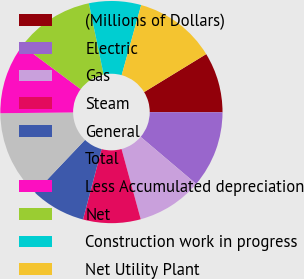Convert chart. <chart><loc_0><loc_0><loc_500><loc_500><pie_chart><fcel>(Millions of Dollars)<fcel>Electric<fcel>Gas<fcel>Steam<fcel>General<fcel>Total<fcel>Less Accumulated depreciation<fcel>Net<fcel>Construction work in progress<fcel>Net Utility Plant<nl><fcel>8.77%<fcel>11.16%<fcel>9.56%<fcel>8.37%<fcel>7.97%<fcel>12.75%<fcel>10.36%<fcel>11.55%<fcel>7.57%<fcel>11.95%<nl></chart> 